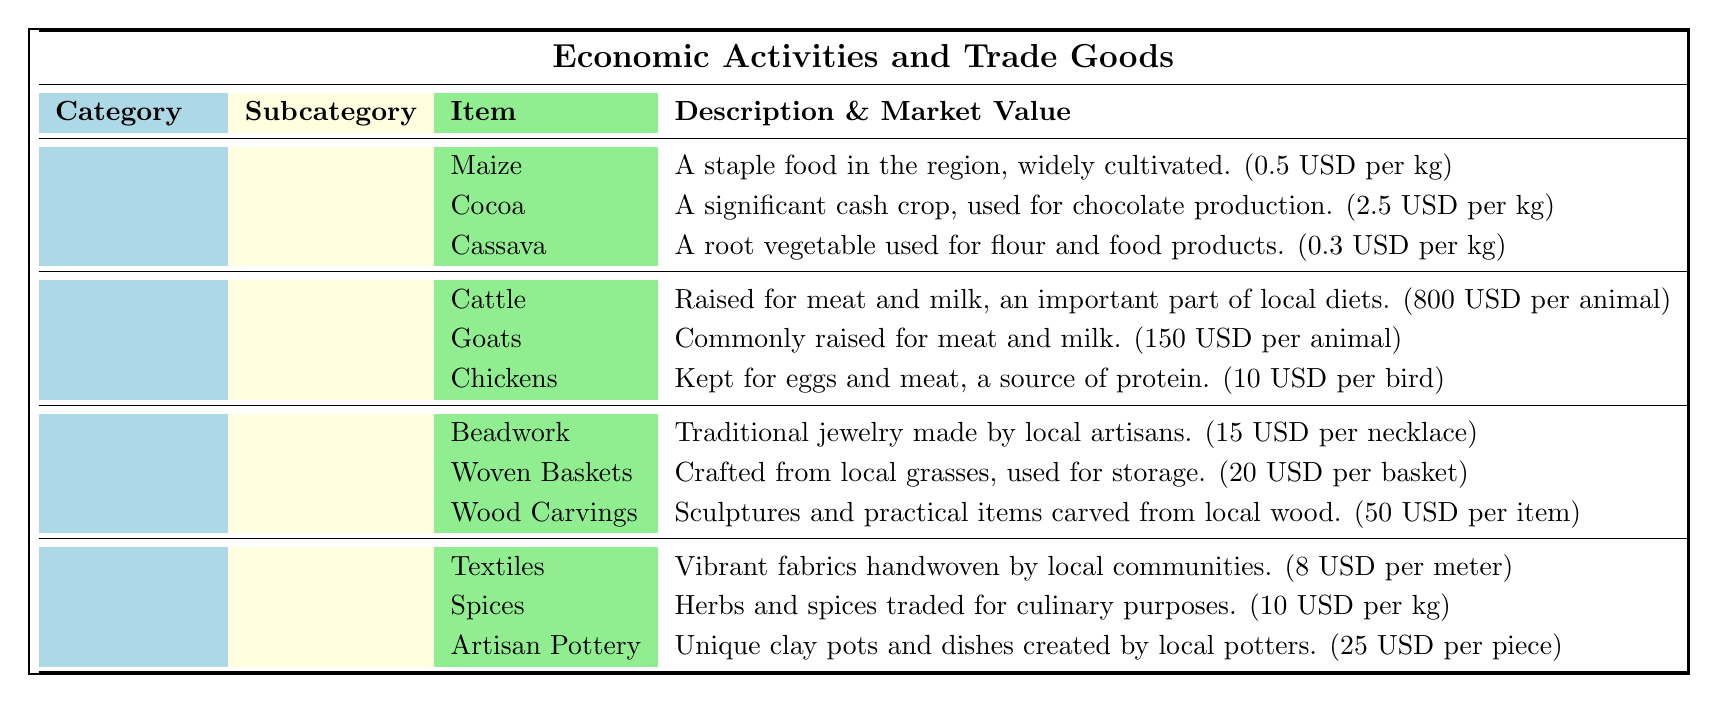What is the market value of maize? The table states that maize has a market value of 0.5 USD per kg.
Answer: 0.5 USD per kg Which livestock item has the highest market value? Cattle have the highest market value listed in the table at 800 USD per animal.
Answer: Cattle Are wooden carvings more expensive than woven baskets? The market value of wood carvings is 50 USD per item, while woven baskets are 20 USD per basket. Thus, wood carvings are indeed more expensive.
Answer: Yes What is the total market value of all crops listed? The market values of the crops are: Maize (0.5 USD), Cocoa (2.5 USD), and Cassava (0.3 USD). The total is 0.5 + 2.5 + 0.3 = 3.3 USD per kg.
Answer: 3.3 USD per kg Is cocoa cultivated primarily for domestic consumption? The description for cocoa indicates it is a significant cash crop used for chocolate production, suggesting it is likely aimed at export rather than solely domestic consumption.
Answer: No What is the combined market value of goats and chickens? The market value for goats is 150 USD and for chickens is 10 USD. Adding these values gives 150 + 10 = 160 USD.
Answer: 160 USD Which handicraft item has the lowest market value? The table indicates that beadwork has the lowest market value at 15 USD per necklace compared to the others.
Answer: Beadwork How does the market value of spices compare to textiles? Spices have a market value of 10 USD per kg while textiles are 8 USD per meter. Since 10 USD is greater than 8 USD, spices are more valuable.
Answer: Spices are more valuable than textiles 